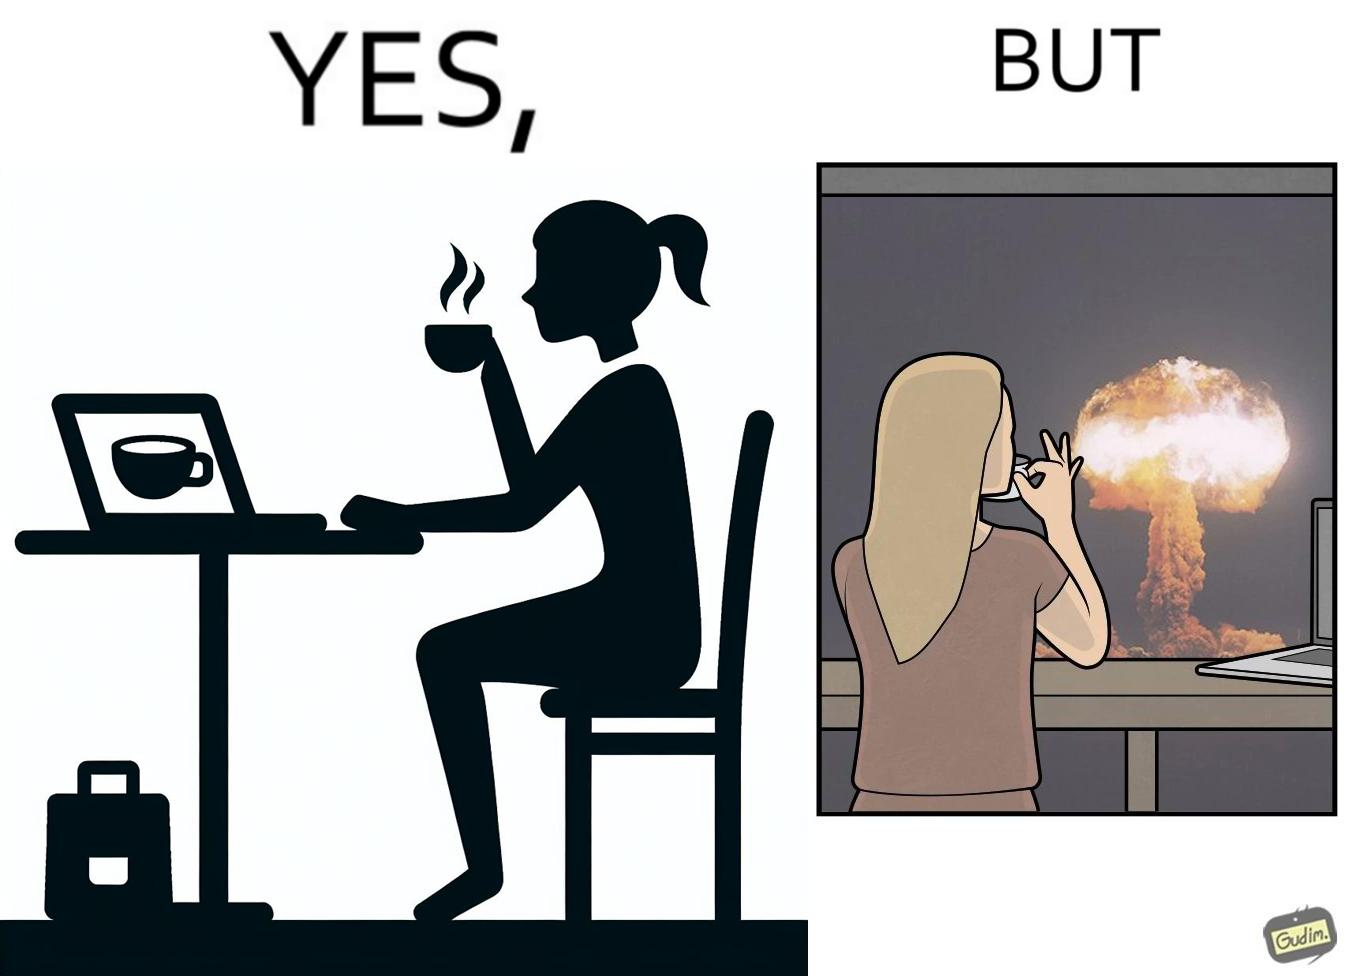Describe what you see in this image. The images are funny since it shows a woman simply sipping from a cup at ease in a cafe with her laptop not caring about anything going on outside the cafe even though the situation is very grave,that is, a nuclear blast 